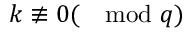<formula> <loc_0><loc_0><loc_500><loc_500>k \not \equiv 0 ( \mod q )</formula> 